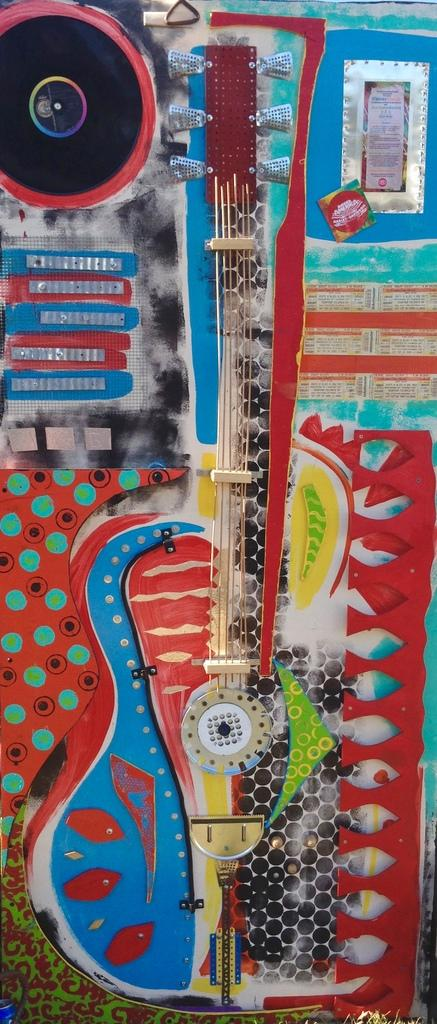What is the main object in the image? There is a board in the image. What is depicted on the board? There is a painting in the image. What else can be seen on the board? There are strings in the image. Are there any other objects visible in the image besides the board and its contents? Yes, there are other unspecified objects in the image. How many cats are sitting on the sack in the image? There are no cats or sacks present in the image. What type of pigs can be seen interacting with the painting on the board? There are no pigs present in the image; the painting and strings are the only visible elements on the board. 